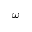<formula> <loc_0><loc_0><loc_500><loc_500>\omega</formula> 